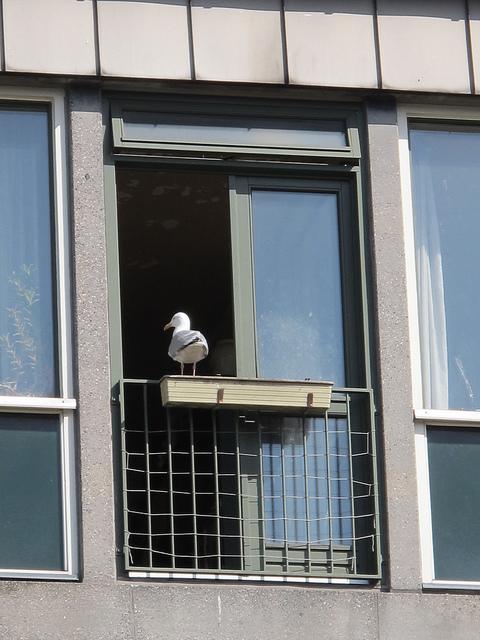Does the bird live there?
Write a very short answer. No. What type of bird is this?
Write a very short answer. Seagull. How many birds are on the left windowsill?
Write a very short answer. 1. Is this animal indoors?
Concise answer only. No. Is the bird looking towards the interior or exterior of the structure?
Short answer required. Interior. 